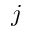Convert formula to latex. <formula><loc_0><loc_0><loc_500><loc_500>j</formula> 